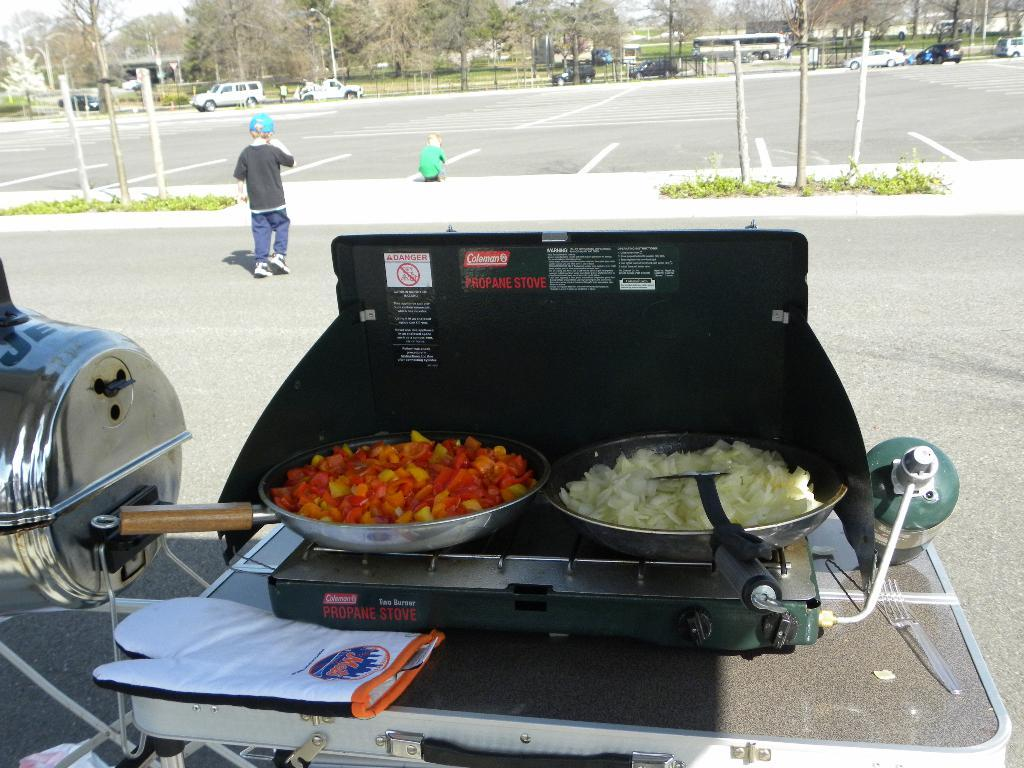<image>
Summarize the visual content of the image. Propane stove two burger from Coleman and a mets logo on a oven mitt. 